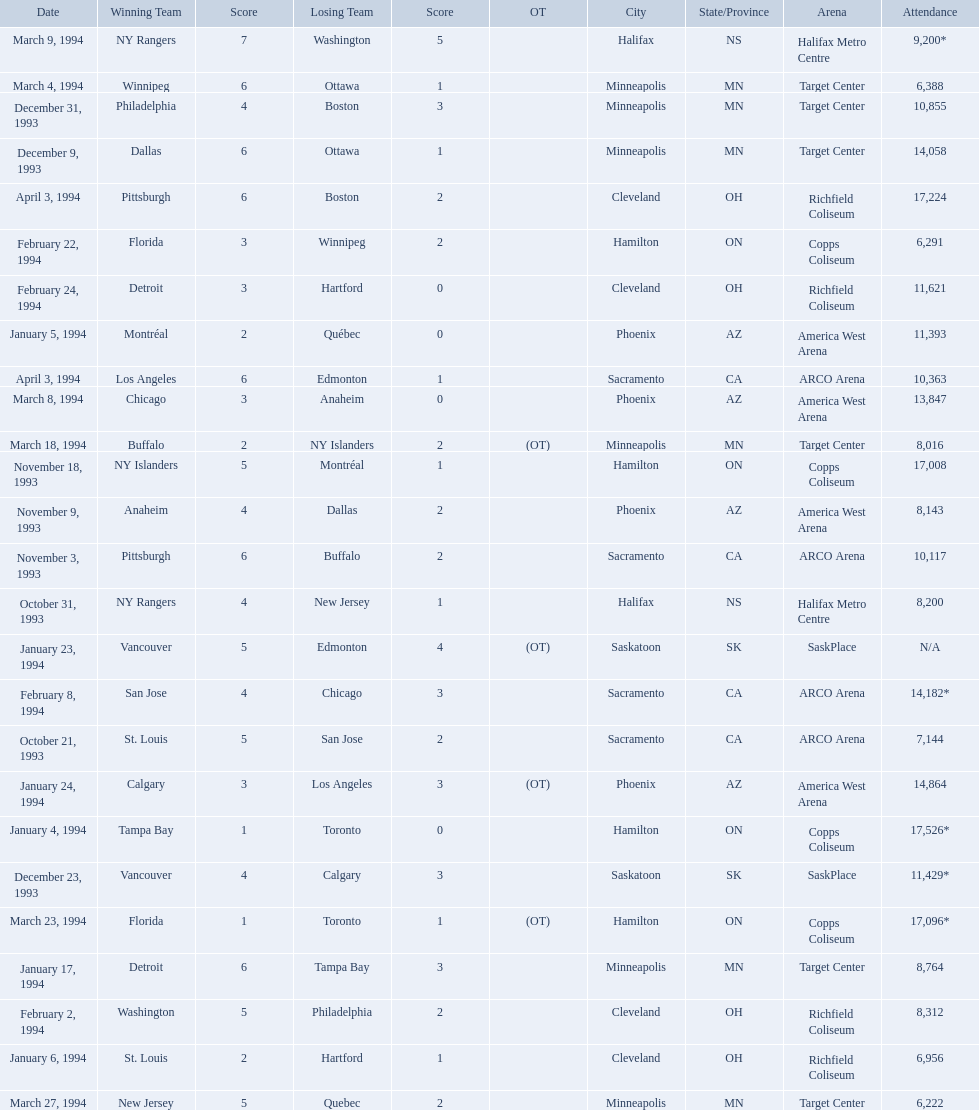Which dates saw the winning team score only one point? January 4, 1994, March 23, 1994. Of these two, which date had higher attendance? January 4, 1994. 